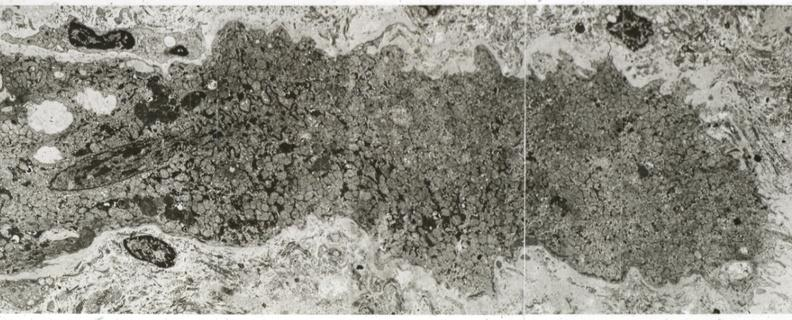does this image show advanced myofiber atrophy?
Answer the question using a single word or phrase. Yes 